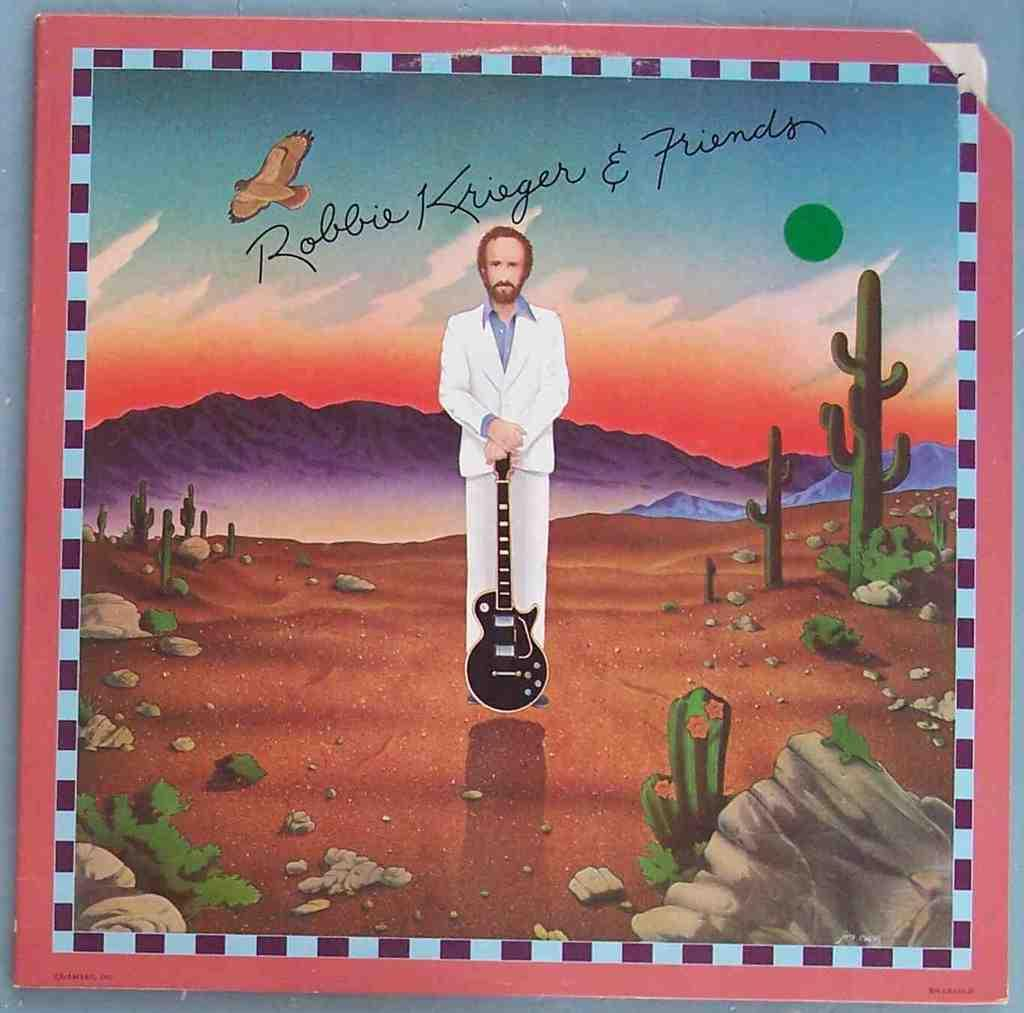<image>
Present a compact description of the photo's key features. Album cover art for Robbie Krieger and Friends includes cacti and a desert scene. 